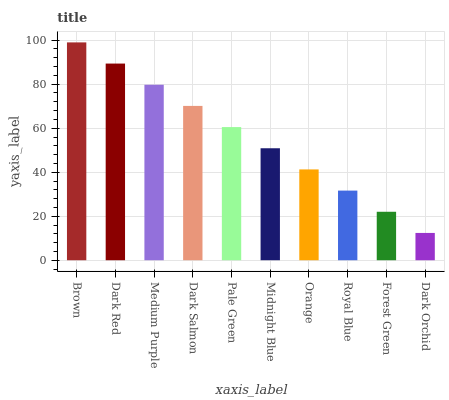Is Dark Orchid the minimum?
Answer yes or no. Yes. Is Brown the maximum?
Answer yes or no. Yes. Is Dark Red the minimum?
Answer yes or no. No. Is Dark Red the maximum?
Answer yes or no. No. Is Brown greater than Dark Red?
Answer yes or no. Yes. Is Dark Red less than Brown?
Answer yes or no. Yes. Is Dark Red greater than Brown?
Answer yes or no. No. Is Brown less than Dark Red?
Answer yes or no. No. Is Pale Green the high median?
Answer yes or no. Yes. Is Midnight Blue the low median?
Answer yes or no. Yes. Is Dark Salmon the high median?
Answer yes or no. No. Is Medium Purple the low median?
Answer yes or no. No. 